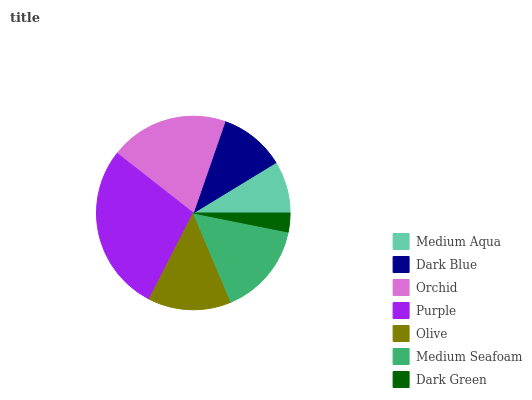Is Dark Green the minimum?
Answer yes or no. Yes. Is Purple the maximum?
Answer yes or no. Yes. Is Dark Blue the minimum?
Answer yes or no. No. Is Dark Blue the maximum?
Answer yes or no. No. Is Dark Blue greater than Medium Aqua?
Answer yes or no. Yes. Is Medium Aqua less than Dark Blue?
Answer yes or no. Yes. Is Medium Aqua greater than Dark Blue?
Answer yes or no. No. Is Dark Blue less than Medium Aqua?
Answer yes or no. No. Is Olive the high median?
Answer yes or no. Yes. Is Olive the low median?
Answer yes or no. Yes. Is Orchid the high median?
Answer yes or no. No. Is Purple the low median?
Answer yes or no. No. 